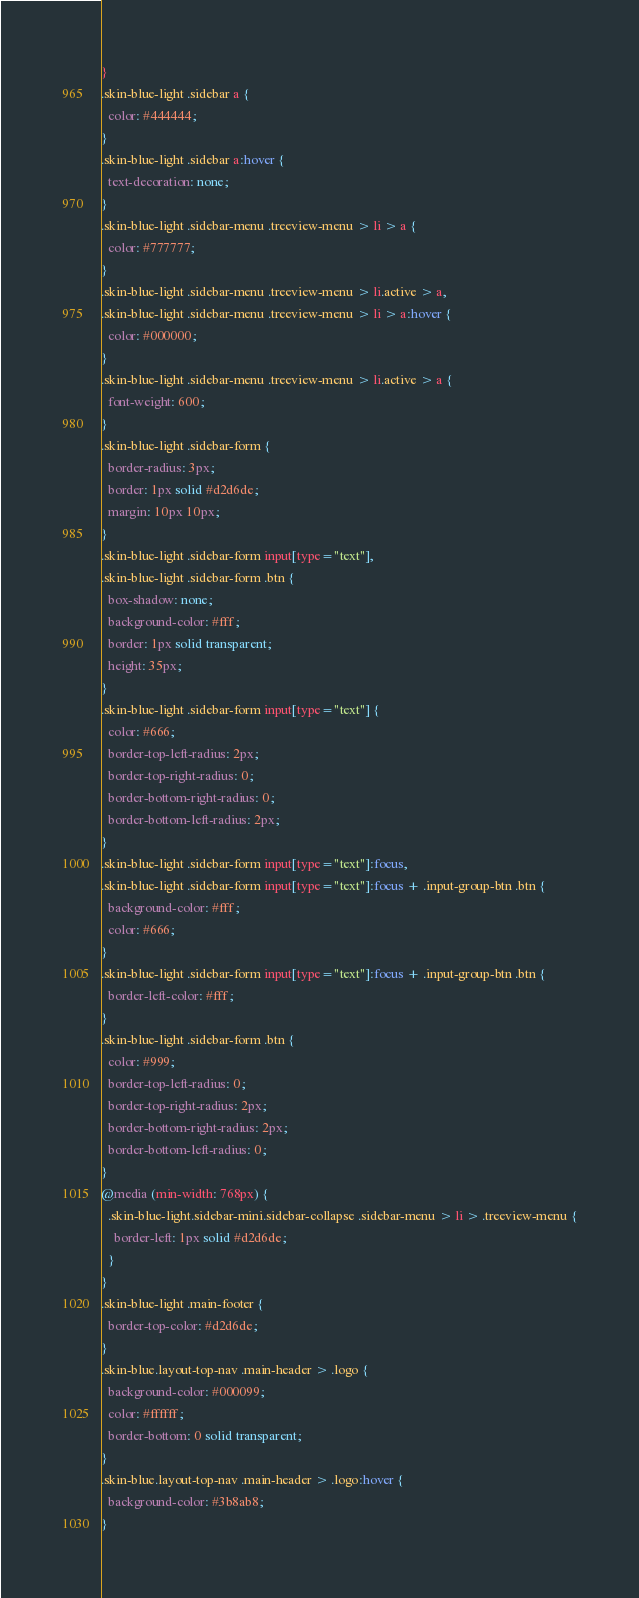Convert code to text. <code><loc_0><loc_0><loc_500><loc_500><_CSS_>}
.skin-blue-light .sidebar a {
  color: #444444;
}
.skin-blue-light .sidebar a:hover {
  text-decoration: none;
}
.skin-blue-light .sidebar-menu .treeview-menu > li > a {
  color: #777777;
}
.skin-blue-light .sidebar-menu .treeview-menu > li.active > a,
.skin-blue-light .sidebar-menu .treeview-menu > li > a:hover {
  color: #000000;
}
.skin-blue-light .sidebar-menu .treeview-menu > li.active > a {
  font-weight: 600;
}
.skin-blue-light .sidebar-form {
  border-radius: 3px;
  border: 1px solid #d2d6de;
  margin: 10px 10px;
}
.skin-blue-light .sidebar-form input[type="text"],
.skin-blue-light .sidebar-form .btn {
  box-shadow: none;
  background-color: #fff;
  border: 1px solid transparent;
  height: 35px;
}
.skin-blue-light .sidebar-form input[type="text"] {
  color: #666;
  border-top-left-radius: 2px;
  border-top-right-radius: 0;
  border-bottom-right-radius: 0;
  border-bottom-left-radius: 2px;
}
.skin-blue-light .sidebar-form input[type="text"]:focus,
.skin-blue-light .sidebar-form input[type="text"]:focus + .input-group-btn .btn {
  background-color: #fff;
  color: #666;
}
.skin-blue-light .sidebar-form input[type="text"]:focus + .input-group-btn .btn {
  border-left-color: #fff;
}
.skin-blue-light .sidebar-form .btn {
  color: #999;
  border-top-left-radius: 0;
  border-top-right-radius: 2px;
  border-bottom-right-radius: 2px;
  border-bottom-left-radius: 0;
}
@media (min-width: 768px) {
  .skin-blue-light.sidebar-mini.sidebar-collapse .sidebar-menu > li > .treeview-menu {
    border-left: 1px solid #d2d6de;
  }
}
.skin-blue-light .main-footer {
  border-top-color: #d2d6de;
}
.skin-blue.layout-top-nav .main-header > .logo {
  background-color: #000099;
  color: #ffffff;
  border-bottom: 0 solid transparent;
}
.skin-blue.layout-top-nav .main-header > .logo:hover {
  background-color: #3b8ab8;
}
</code> 